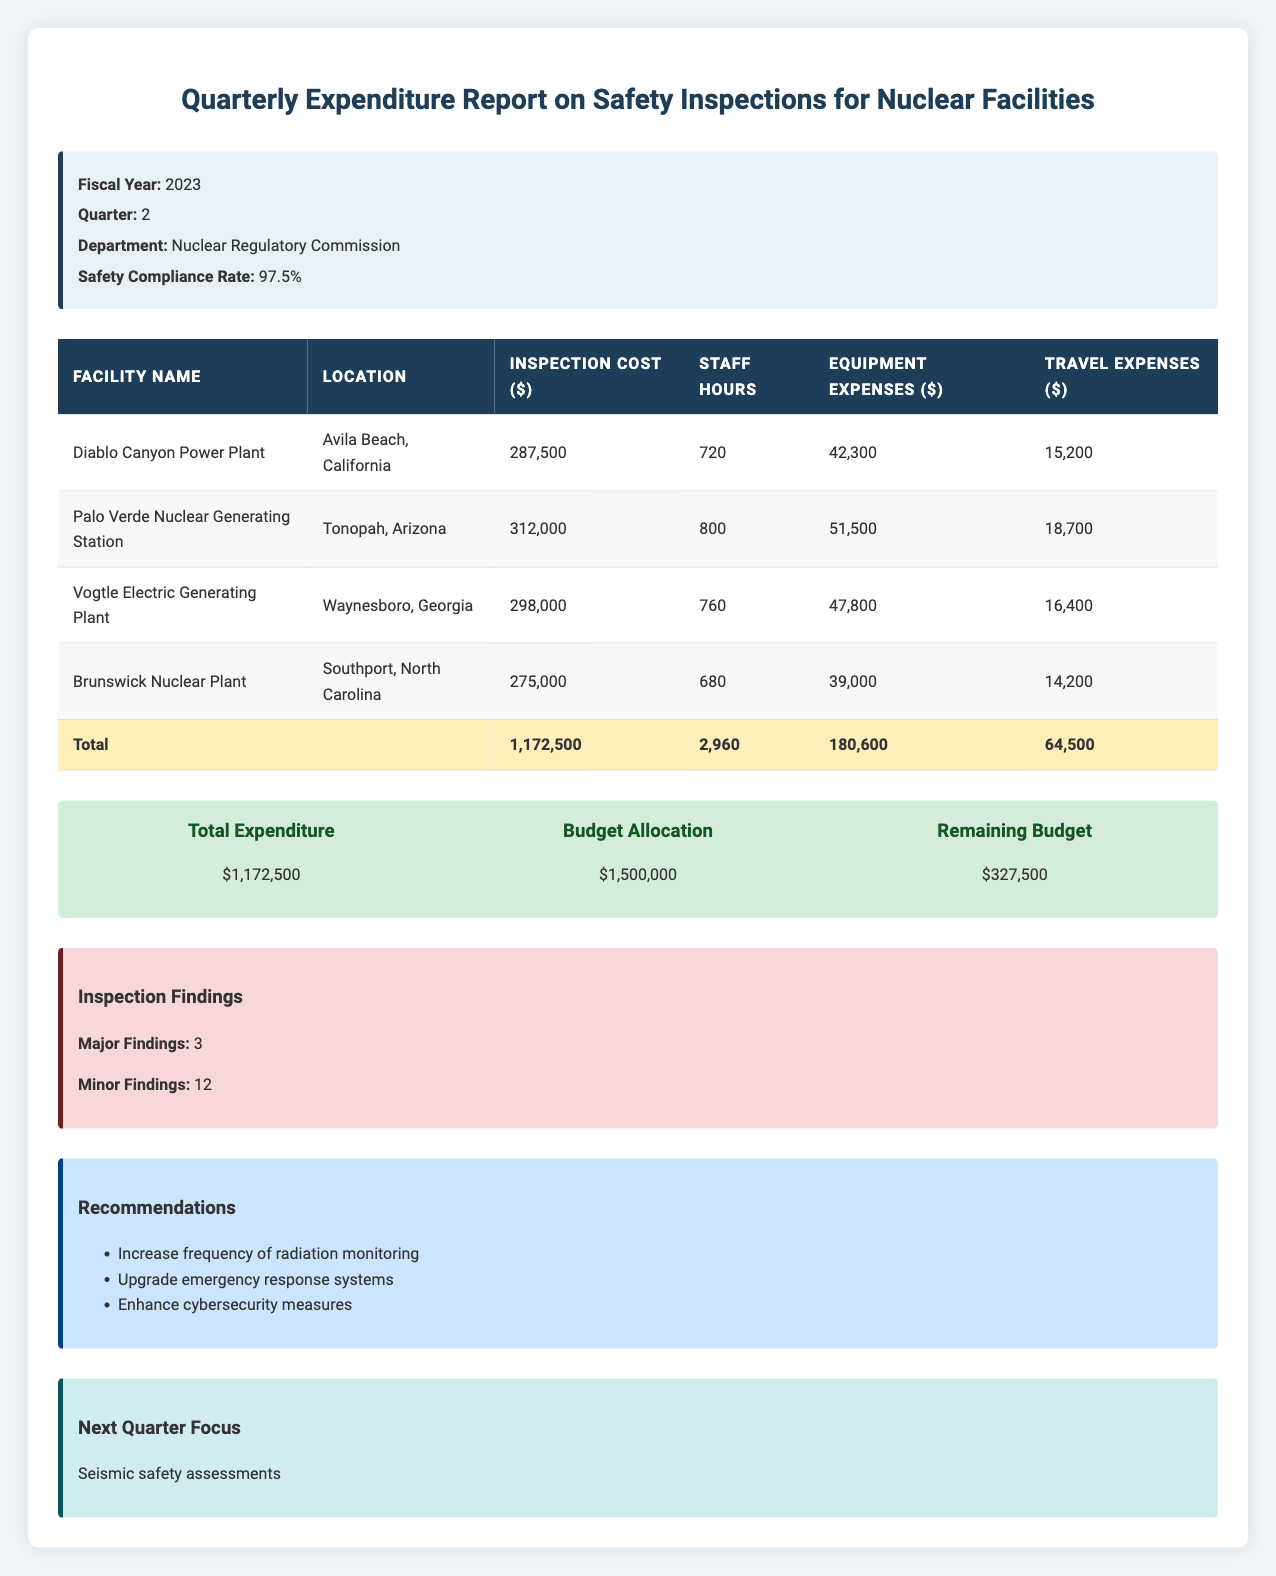What is the total inspection cost for the Diablo Canyon Power Plant? The inspection cost for the Diablo Canyon Power Plant is listed as 287,500 in the table.
Answer: 287500 Which facility incurred the highest travel expenses? By comparing the travel expenses for each facility: Diablo Canyon Power Plant (15,200), Palo Verde (18,700), Vogtle (16,400), and Brunswick (14,200), Palo Verde Nuclear Generating Station has the highest at 18,700.
Answer: Palo Verde Nuclear Generating Station How much was spent on equipment across all facilities? To find the total equipment expenses, we sum the equipment expenses of all facilities: 42,300 (Diablo Canyon) + 51,500 (Palo Verde) + 47,800 (Vogtle) + 39,000 (Brunswick) = 180,600.
Answer: 180600 Is the safety compliance rate higher than 95%? The safety compliance rate is stated as 97.5% in the report, which is indeed higher than 95%.
Answer: Yes What are the major findings from the safety inspections? The report specifies that there were a total of 3 major findings resulting from the safety inspections.
Answer: 3 What is the difference between the budget allocation and total expenditure? The budget allocation is 1,500,000, and the total expenditure is 1,172,500. Subtracting these gives: 1,500,000 - 1,172,500 = 327,500.
Answer: 327500 Which facility had the lowest total inspection cost? The inspection costs are: Diablo Canyon (287,500), Palo Verde (312,000), Vogtle (298,000), and Brunswick (275,000). The lowest is Brunswick with 275,000.
Answer: Brunswick Nuclear Plant What percentage of the total budget is remaining after the expenditures? The remaining budget is 327,500, and the initial budget allocation is 1,500,000. To find the percentage: (327,500 / 1,500,000) * 100 = 21.83%.
Answer: 21.83% What are the recommendations made after the inspections? The report lists three recommendations: increase frequency of radiation monitoring, upgrade emergency response systems, and enhance cybersecurity measures.
Answer: Increase frequency of radiation monitoring; Upgrade emergency response systems; Enhance cybersecurity measures 